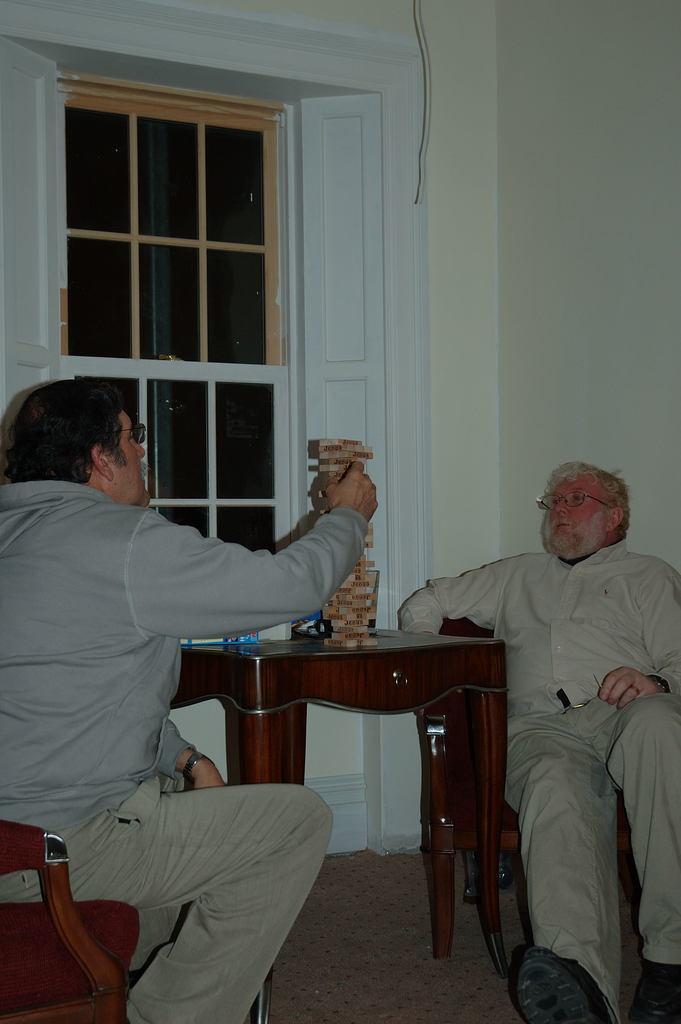Could you give a brief overview of what you see in this image? Here we can see two old men sitting on chairs with a table in front of them and beside them we can see a window 